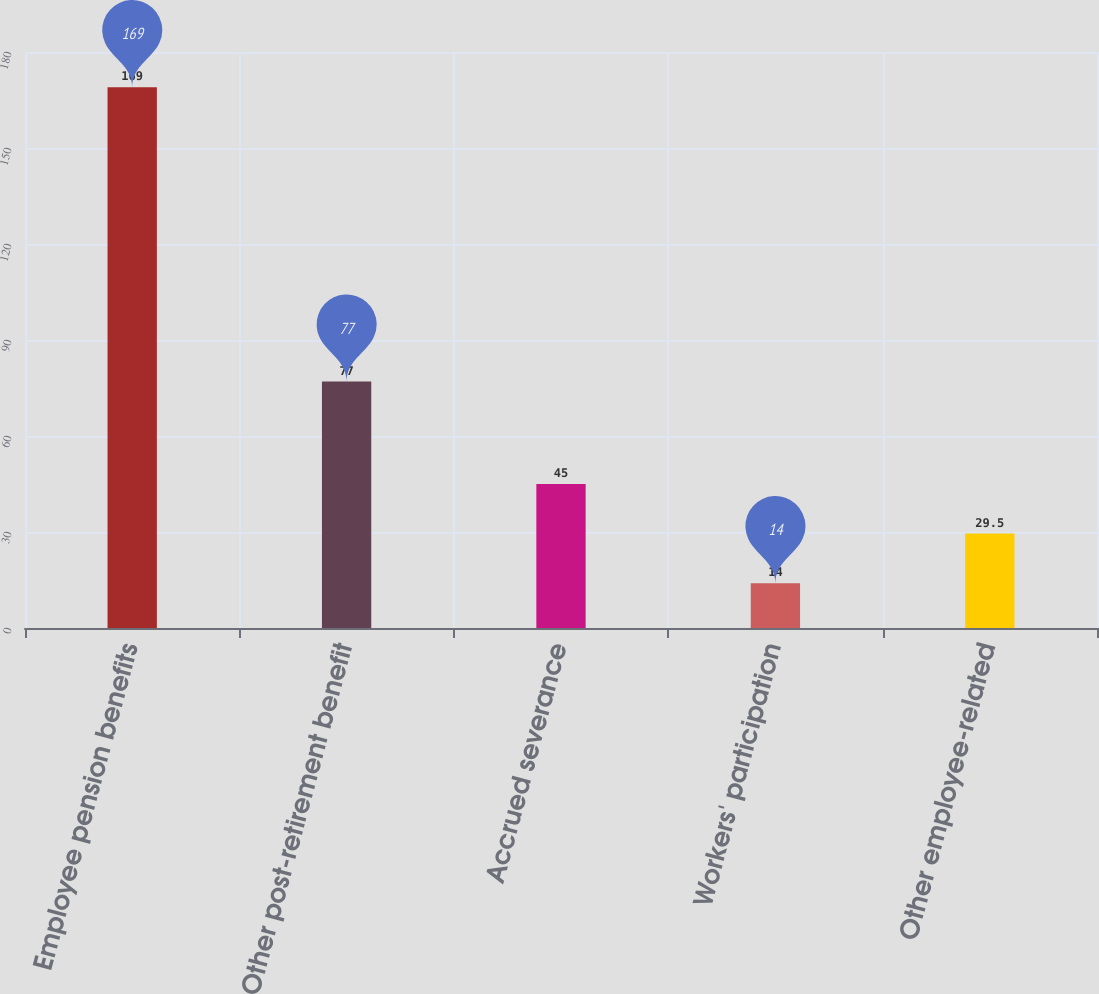Convert chart. <chart><loc_0><loc_0><loc_500><loc_500><bar_chart><fcel>Employee pension benefits<fcel>Other post-retirement benefit<fcel>Accrued severance<fcel>Workers' participation<fcel>Other employee-related<nl><fcel>169<fcel>77<fcel>45<fcel>14<fcel>29.5<nl></chart> 